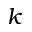<formula> <loc_0><loc_0><loc_500><loc_500>k</formula> 